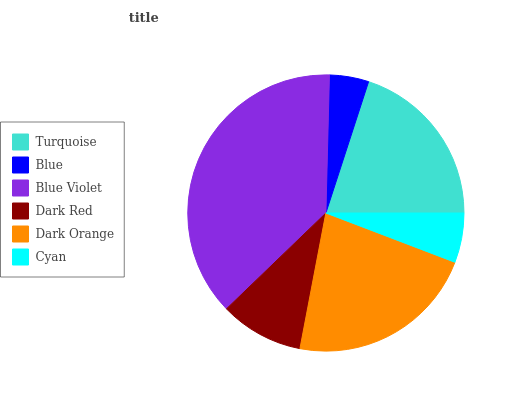Is Blue the minimum?
Answer yes or no. Yes. Is Blue Violet the maximum?
Answer yes or no. Yes. Is Blue Violet the minimum?
Answer yes or no. No. Is Blue the maximum?
Answer yes or no. No. Is Blue Violet greater than Blue?
Answer yes or no. Yes. Is Blue less than Blue Violet?
Answer yes or no. Yes. Is Blue greater than Blue Violet?
Answer yes or no. No. Is Blue Violet less than Blue?
Answer yes or no. No. Is Turquoise the high median?
Answer yes or no. Yes. Is Dark Red the low median?
Answer yes or no. Yes. Is Dark Orange the high median?
Answer yes or no. No. Is Turquoise the low median?
Answer yes or no. No. 